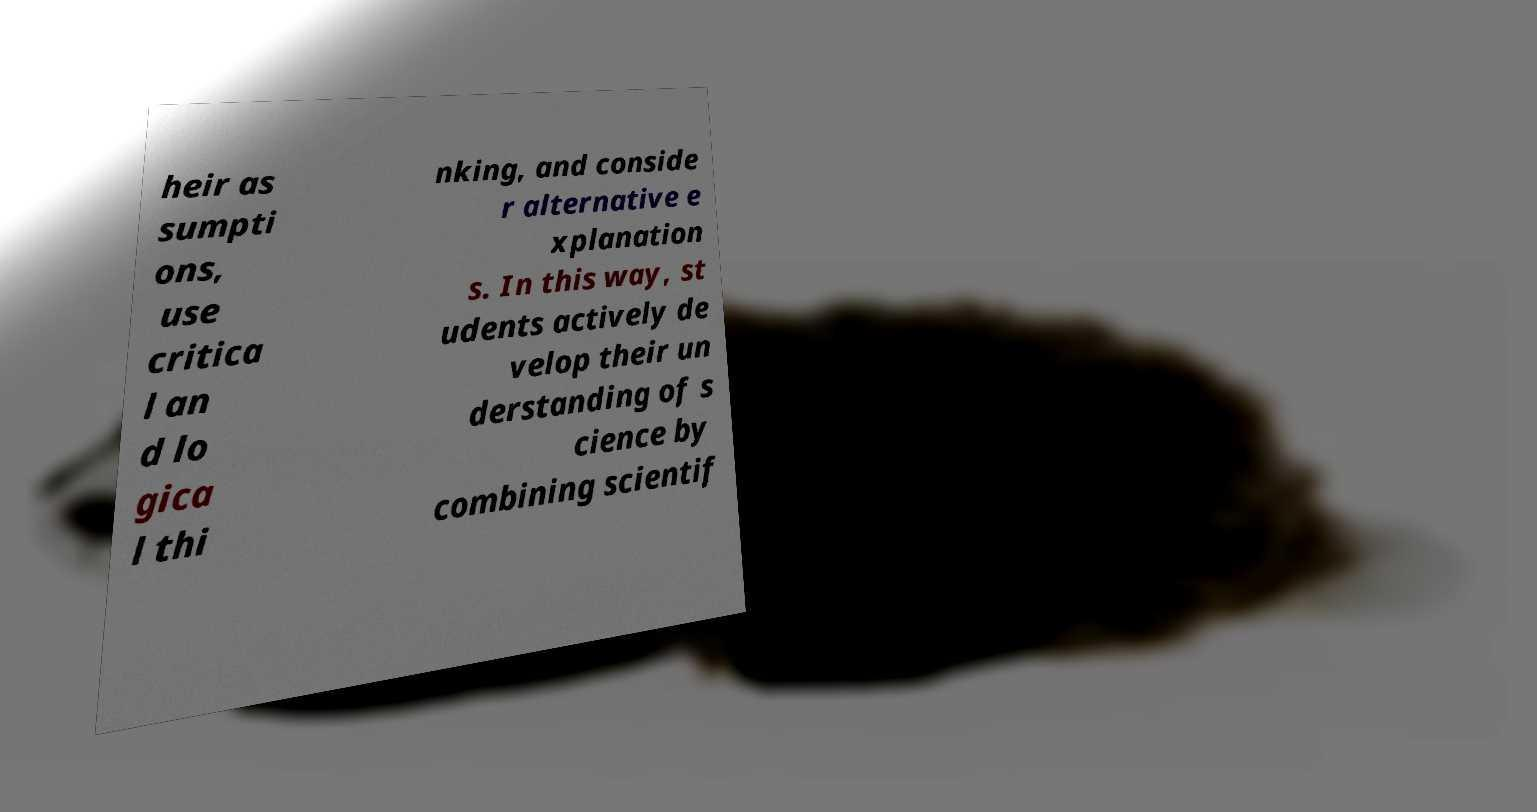Could you extract and type out the text from this image? heir as sumpti ons, use critica l an d lo gica l thi nking, and conside r alternative e xplanation s. In this way, st udents actively de velop their un derstanding of s cience by combining scientif 